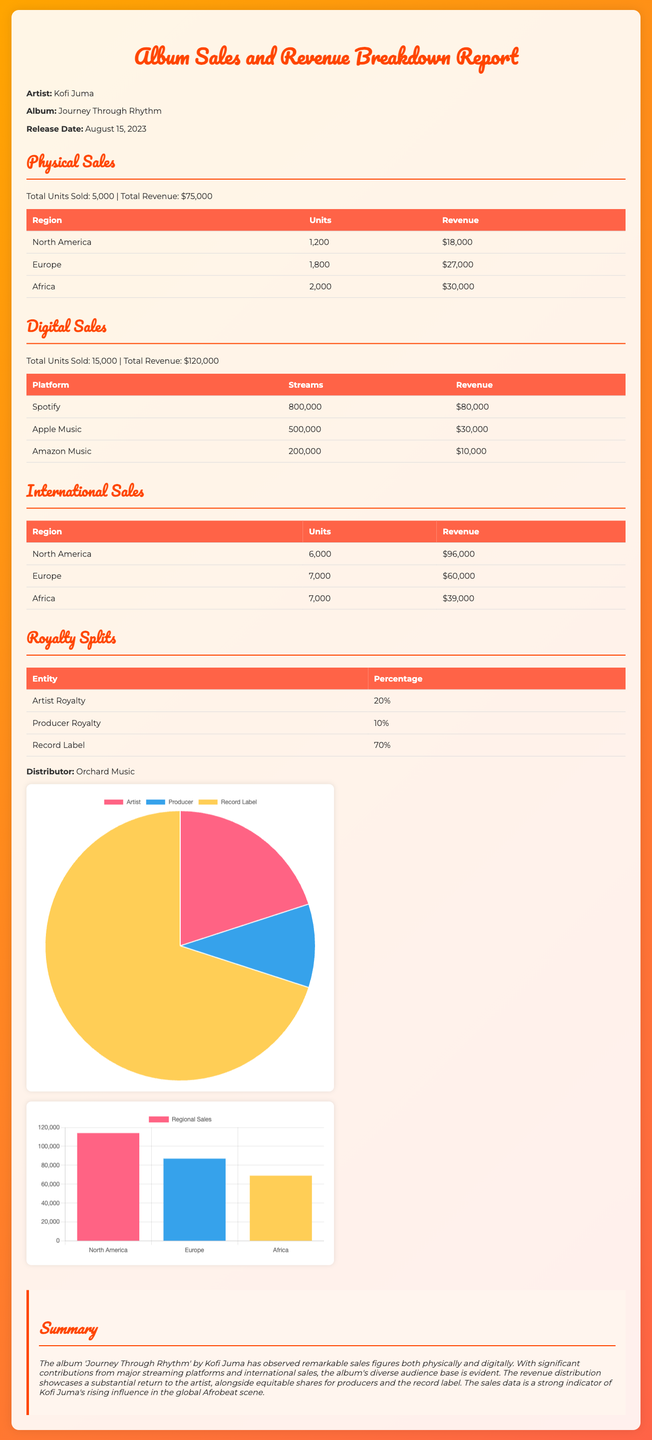What is the total physical sales revenue? The total physical sales revenue is clearly stated in the document as $75,000.
Answer: $75,000 How many units were sold in Europe for physical sales? The document specifies that 1,800 units were sold in Europe for physical sales.
Answer: 1,800 What is the total revenue from digital sales? The document provides a total revenue figure from digital sales, which is $120,000.
Answer: $120,000 Which streaming platform generated the highest revenue? According to the document, Spotify generated the highest revenue at $80,000.
Answer: Spotify What is the royalty percentage for the Record Label? The document states that the royalty percentage for the Record Label is 70%.
Answer: 70% What is the total number of units sold internationally? The total number of international units sold is 20,000, calculated by summing all regions.
Answer: 20,000 Which region had the highest revenue from international sales? The document indicates that North America had the highest revenue from international sales at $96,000.
Answer: North America What percentage of the total revenue does the artist receive? The document shows that the artist receives 20% of the total revenue.
Answer: 20% How many units were sold on Apple Music? The document states that 500,000 units were sold on Apple Music.
Answer: 500,000 